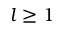<formula> <loc_0><loc_0><loc_500><loc_500>l \geq 1</formula> 